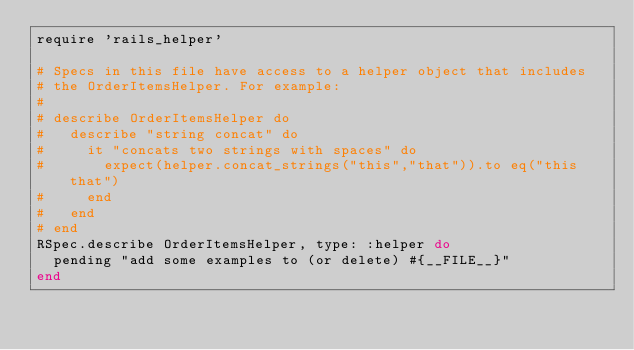<code> <loc_0><loc_0><loc_500><loc_500><_Ruby_>require 'rails_helper'

# Specs in this file have access to a helper object that includes
# the OrderItemsHelper. For example:
#
# describe OrderItemsHelper do
#   describe "string concat" do
#     it "concats two strings with spaces" do
#       expect(helper.concat_strings("this","that")).to eq("this that")
#     end
#   end
# end
RSpec.describe OrderItemsHelper, type: :helper do
  pending "add some examples to (or delete) #{__FILE__}"
end
</code> 